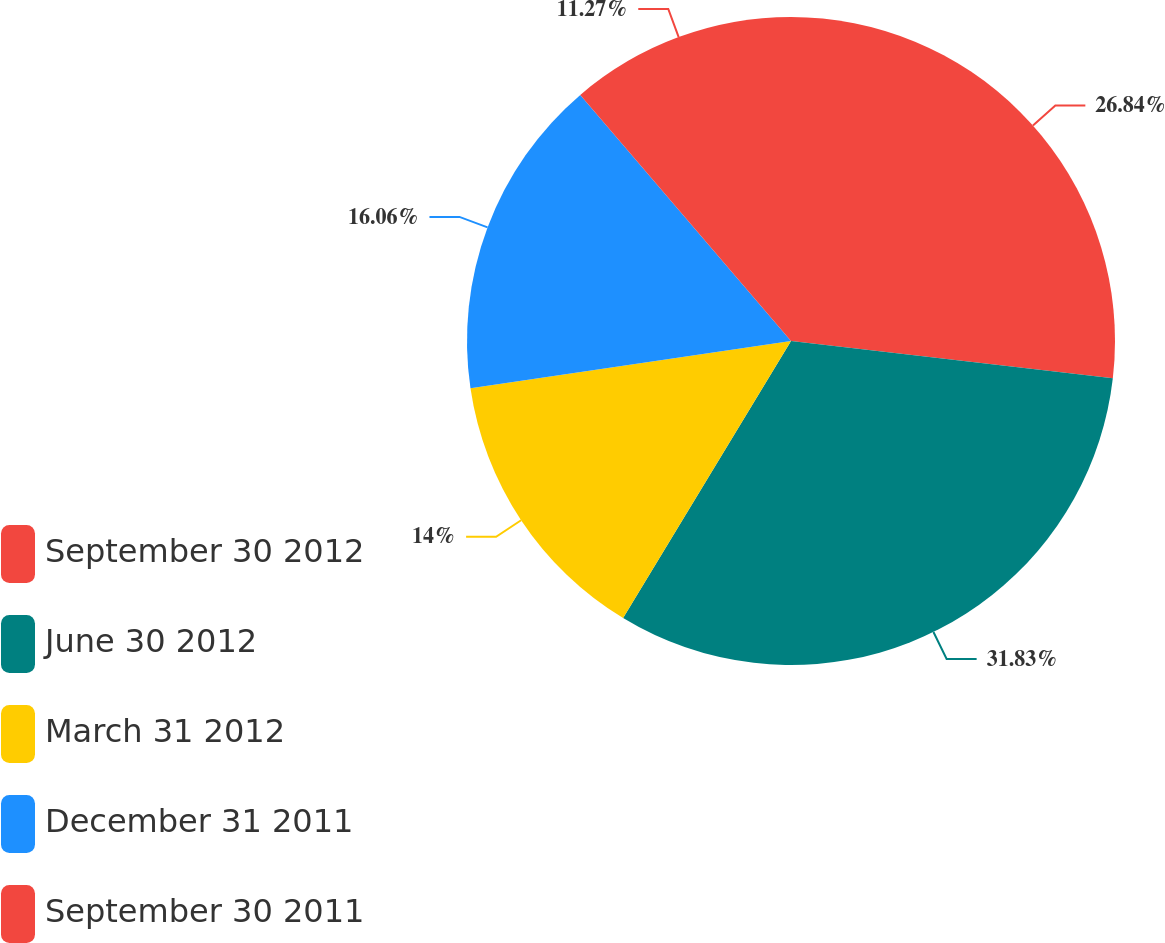Convert chart to OTSL. <chart><loc_0><loc_0><loc_500><loc_500><pie_chart><fcel>September 30 2012<fcel>June 30 2012<fcel>March 31 2012<fcel>December 31 2011<fcel>September 30 2011<nl><fcel>26.84%<fcel>31.83%<fcel>14.0%<fcel>16.06%<fcel>11.27%<nl></chart> 